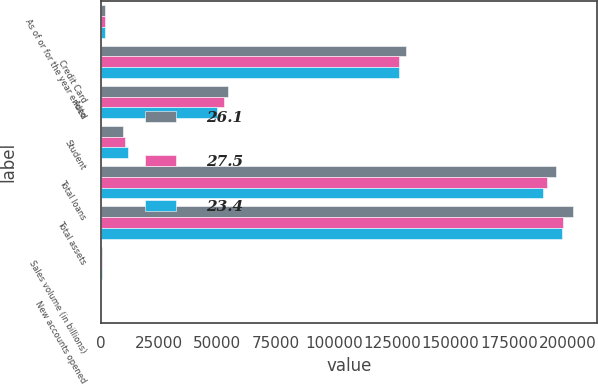Convert chart to OTSL. <chart><loc_0><loc_0><loc_500><loc_500><stacked_bar_chart><ecel><fcel>As of or for the year ended<fcel>Credit Card<fcel>Auto<fcel>Student<fcel>Total loans<fcel>Total assets<fcel>Sales volume (in billions)<fcel>New accounts opened<nl><fcel>26.1<fcel>2014<fcel>131048<fcel>54536<fcel>9351<fcel>194935<fcel>202609<fcel>465.6<fcel>8.8<nl><fcel>27.5<fcel>2013<fcel>127791<fcel>52757<fcel>10541<fcel>191089<fcel>198265<fcel>419.5<fcel>7.3<nl><fcel>23.4<fcel>2012<fcel>127993<fcel>49913<fcel>11558<fcel>189464<fcel>197661<fcel>381.1<fcel>6.7<nl></chart> 